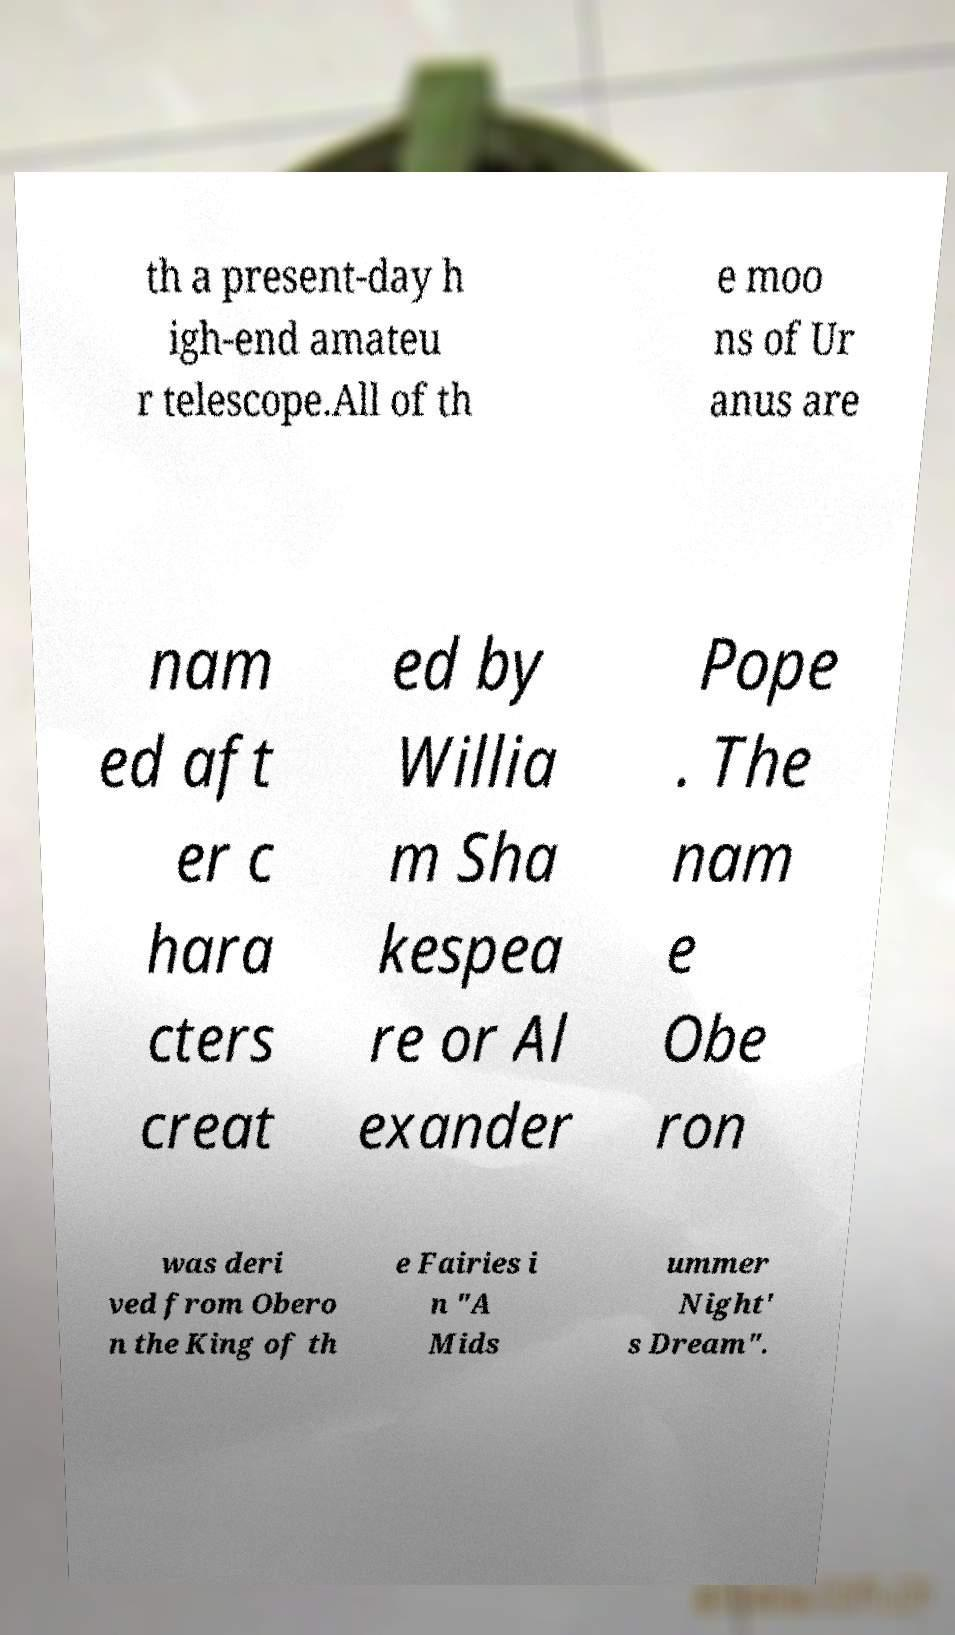Could you extract and type out the text from this image? th a present-day h igh-end amateu r telescope.All of th e moo ns of Ur anus are nam ed aft er c hara cters creat ed by Willia m Sha kespea re or Al exander Pope . The nam e Obe ron was deri ved from Obero n the King of th e Fairies i n "A Mids ummer Night' s Dream". 